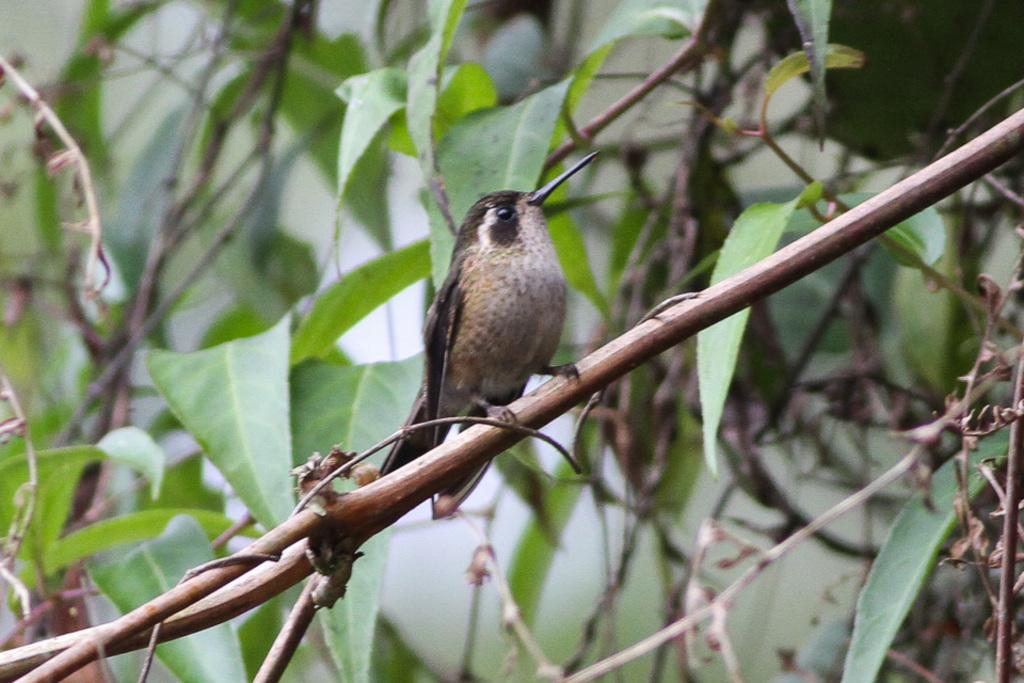What type of animal can be seen in the image? There is a bird in the image. Can you describe the bird's appearance? The bird is brown and white in color. Where is the bird located in the image? The bird is on a thin branch. What can be seen in the background of the image? There are green leaves visible in the background. What type of rifle is the bird holding in the image? There is no rifle present in the image; it features a bird on a thin branch with green leaves in the background. Can you describe the squirrel's interaction with the bird in the image? There is no squirrel present in the image; it only features a bird on a thin branch with green leaves in the background. 